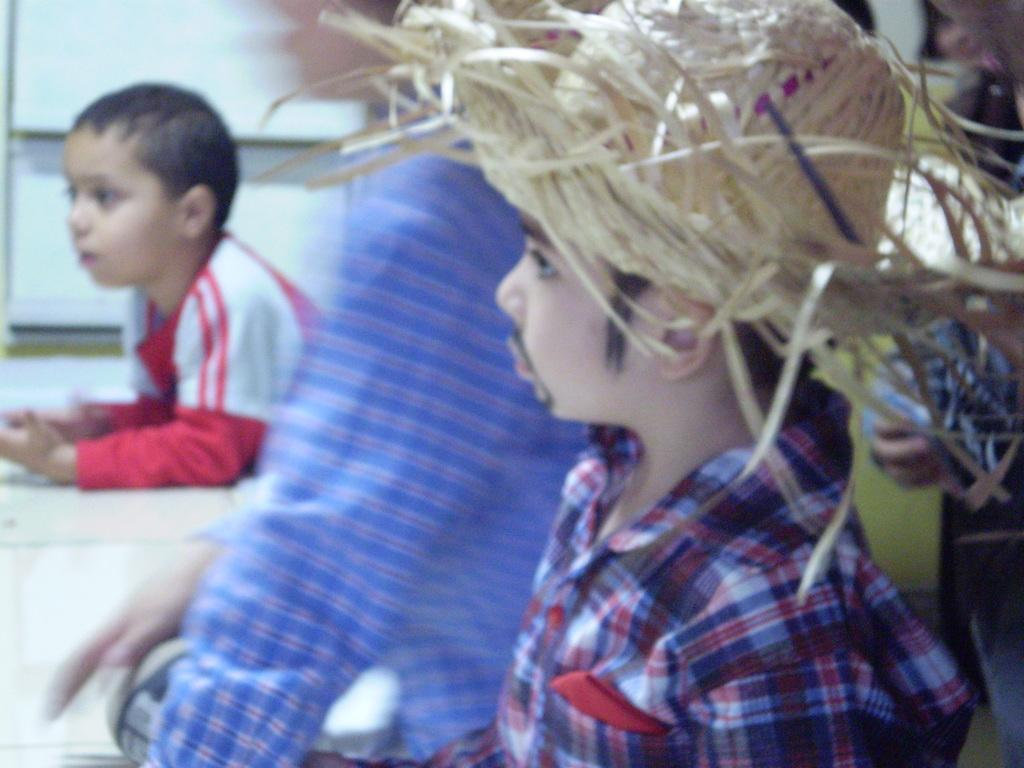Who or what can be seen in the image? There are people in the image. What object is present in the image that is typically used for teaching or presentations? There is a white color board in the image. What type of plantation can be seen in the image? There is no plantation present in the image; it features people and a white color board. Can you locate a map in the image? There is no map present in the image. 